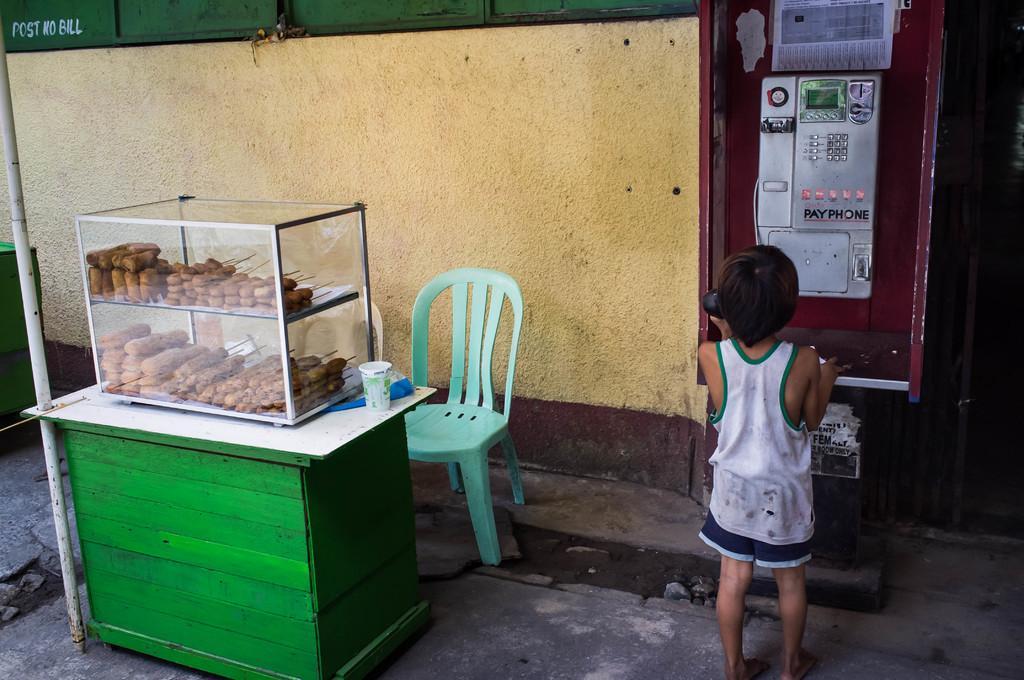In one or two sentences, can you explain what this image depicts? In the image we can see there is a person who is standing and on the table there are food items and there is a chair which is in green colour. 